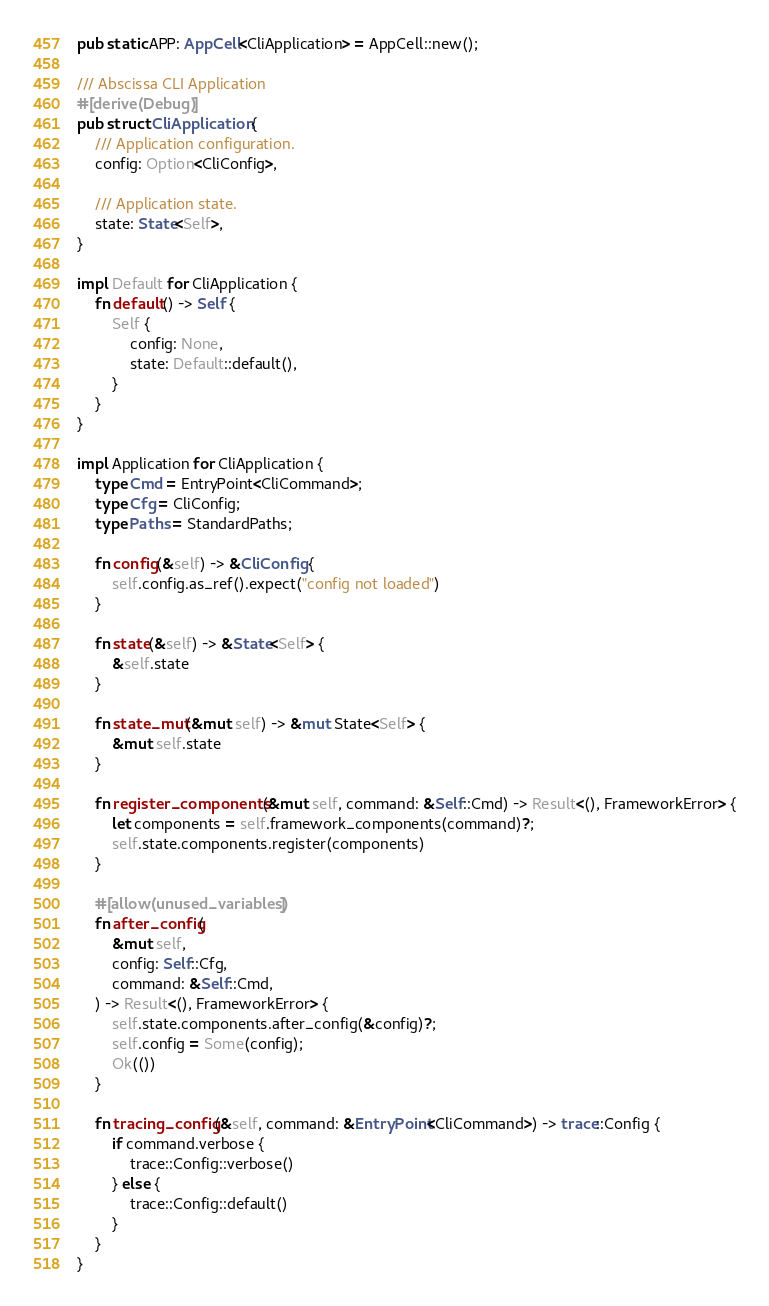Convert code to text. <code><loc_0><loc_0><loc_500><loc_500><_Rust_>pub static APP: AppCell<CliApplication> = AppCell::new();

/// Abscissa CLI Application
#[derive(Debug)]
pub struct CliApplication {
    /// Application configuration.
    config: Option<CliConfig>,

    /// Application state.
    state: State<Self>,
}

impl Default for CliApplication {
    fn default() -> Self {
        Self {
            config: None,
            state: Default::default(),
        }
    }
}

impl Application for CliApplication {
    type Cmd = EntryPoint<CliCommand>;
    type Cfg = CliConfig;
    type Paths = StandardPaths;

    fn config(&self) -> &CliConfig {
        self.config.as_ref().expect("config not loaded")
    }

    fn state(&self) -> &State<Self> {
        &self.state
    }

    fn state_mut(&mut self) -> &mut State<Self> {
        &mut self.state
    }

    fn register_components(&mut self, command: &Self::Cmd) -> Result<(), FrameworkError> {
        let components = self.framework_components(command)?;
        self.state.components.register(components)
    }

    #[allow(unused_variables)]
    fn after_config(
        &mut self,
        config: Self::Cfg,
        command: &Self::Cmd,
    ) -> Result<(), FrameworkError> {
        self.state.components.after_config(&config)?;
        self.config = Some(config);
        Ok(())
    }

    fn tracing_config(&self, command: &EntryPoint<CliCommand>) -> trace::Config {
        if command.verbose {
            trace::Config::verbose()
        } else {
            trace::Config::default()
        }
    }
}
</code> 